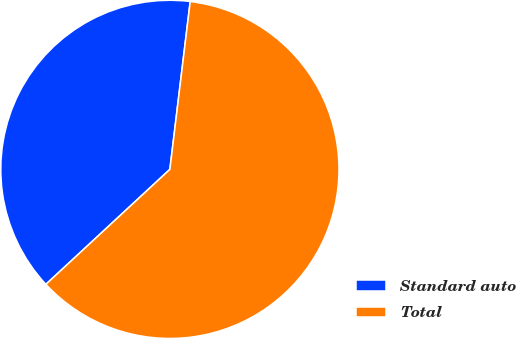<chart> <loc_0><loc_0><loc_500><loc_500><pie_chart><fcel>Standard auto<fcel>Total<nl><fcel>38.82%<fcel>61.18%<nl></chart> 